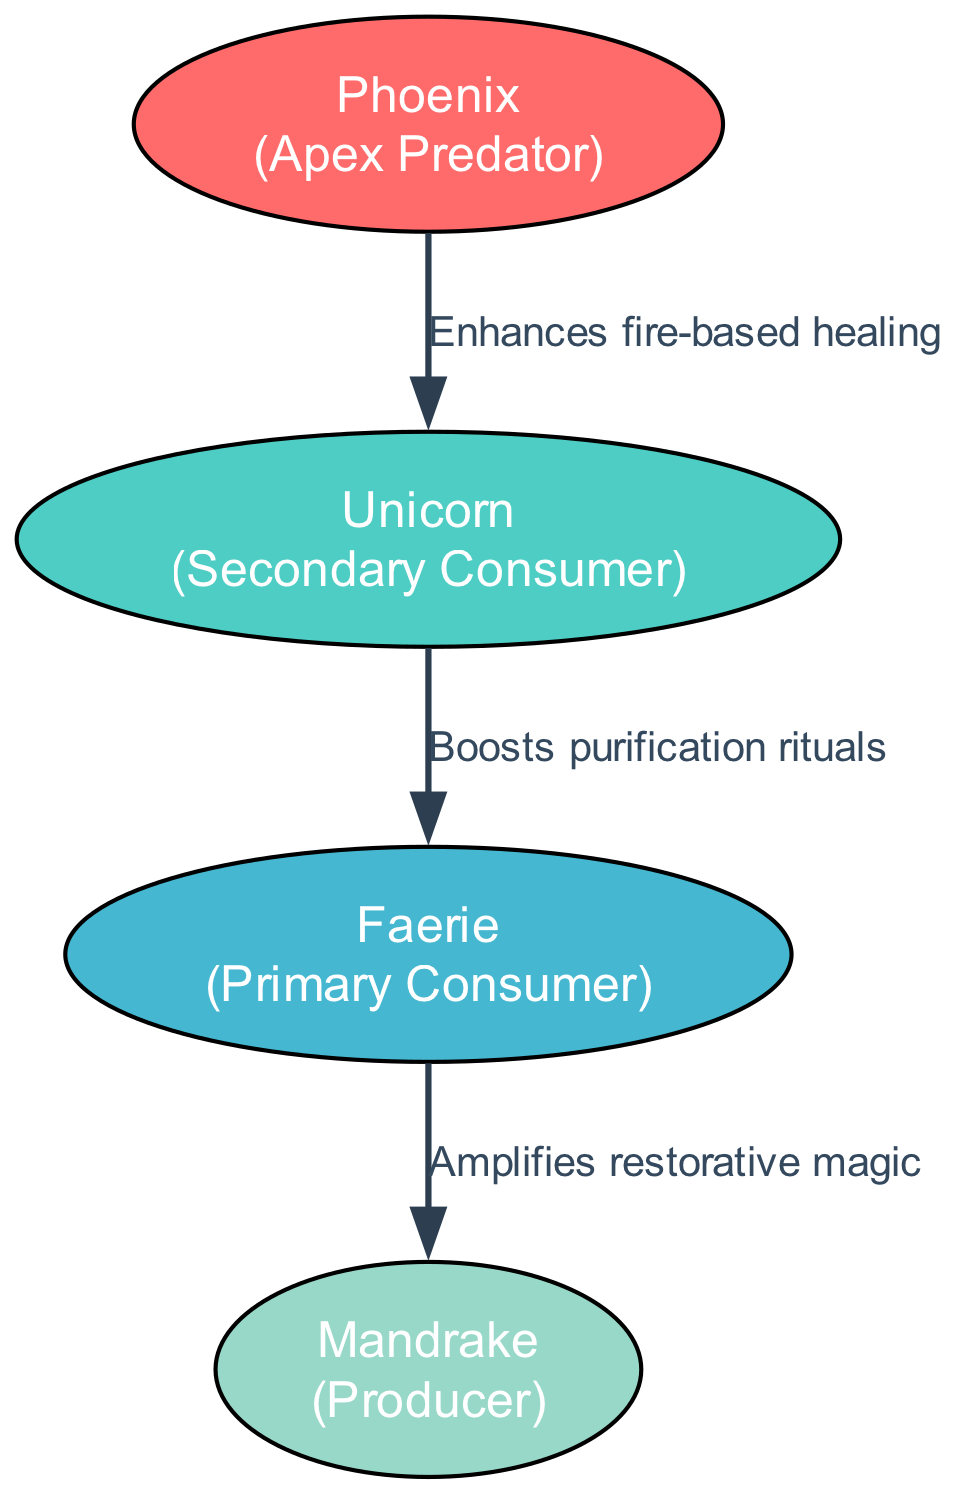What creature is at the Apex Predator level? The diagram indicates that the creature at the Apex Predator level is the Phoenix, as labeled next to this level in the diagram.
Answer: Phoenix How many creatures are there in the food chain? By counting the total number of distinct creatures listed in the trophic levels, we find four: Phoenix, Unicorn, Faerie, and Mandrake.
Answer: 4 What effect does the Unicorn have on the Faerie? Looking at the connecting edge between Unicorn and Faerie, it is labeled "Boosts purification rituals," indicating the specific effect.
Answer: Boosts purification rituals Which creature is a Primary Consumer? The diagram clearly states that the creature identified as a Primary Consumer is the Faerie, based on its categorization in the trophic levels.
Answer: Faerie What is the effect of the Faerie on the Mandrake? The connection between the Faerie and Mandrake states "Amplifies restorative magic," providing the specific effect of this relationship in the diagram.
Answer: Amplifies restorative magic Which creatures are classified as Secondary Consumers? The trophic levels specifically identify the Unicorn as the only creature listed under Secondary Consumer, making it the sole representative of this category.
Answer: Unicorn What is the role of the Mandrake in the food chain? Mandrake serves as the Producer in the food chain, which is explicitly denoted in the trophic levels in the diagram.
Answer: Producer How does the Phoenix affect the Unicorn? The connection shows that the Phoenix enhances fire-based healing, which specifies the effect it has on the Unicorn in the food chain.
Answer: Enhances fire-based healing What is the trophic level of the Unicorn? The diagram clearly indicates that the Unicorn is categorized under the Secondary Consumer level among the other creatures in the food chain.
Answer: Secondary Consumer 